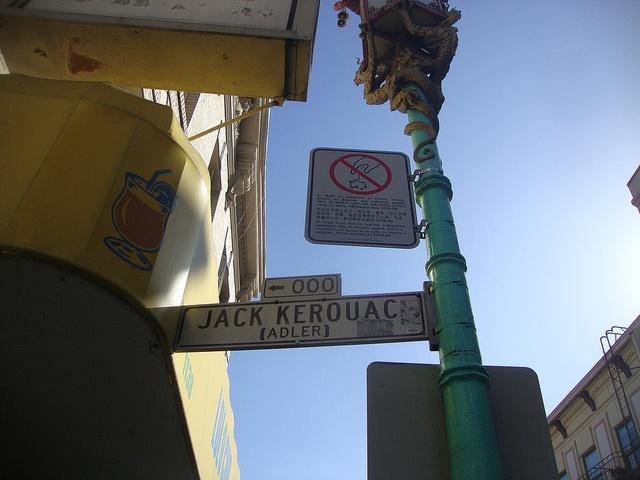Describe the objects in this image and their specific colors. I can see various objects in this image with different colors. 